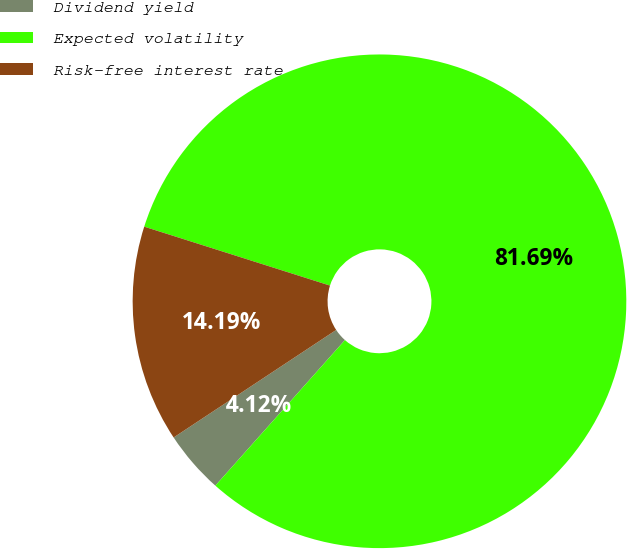Convert chart to OTSL. <chart><loc_0><loc_0><loc_500><loc_500><pie_chart><fcel>Dividend yield<fcel>Expected volatility<fcel>Risk-free interest rate<nl><fcel>4.12%<fcel>81.68%<fcel>14.19%<nl></chart> 